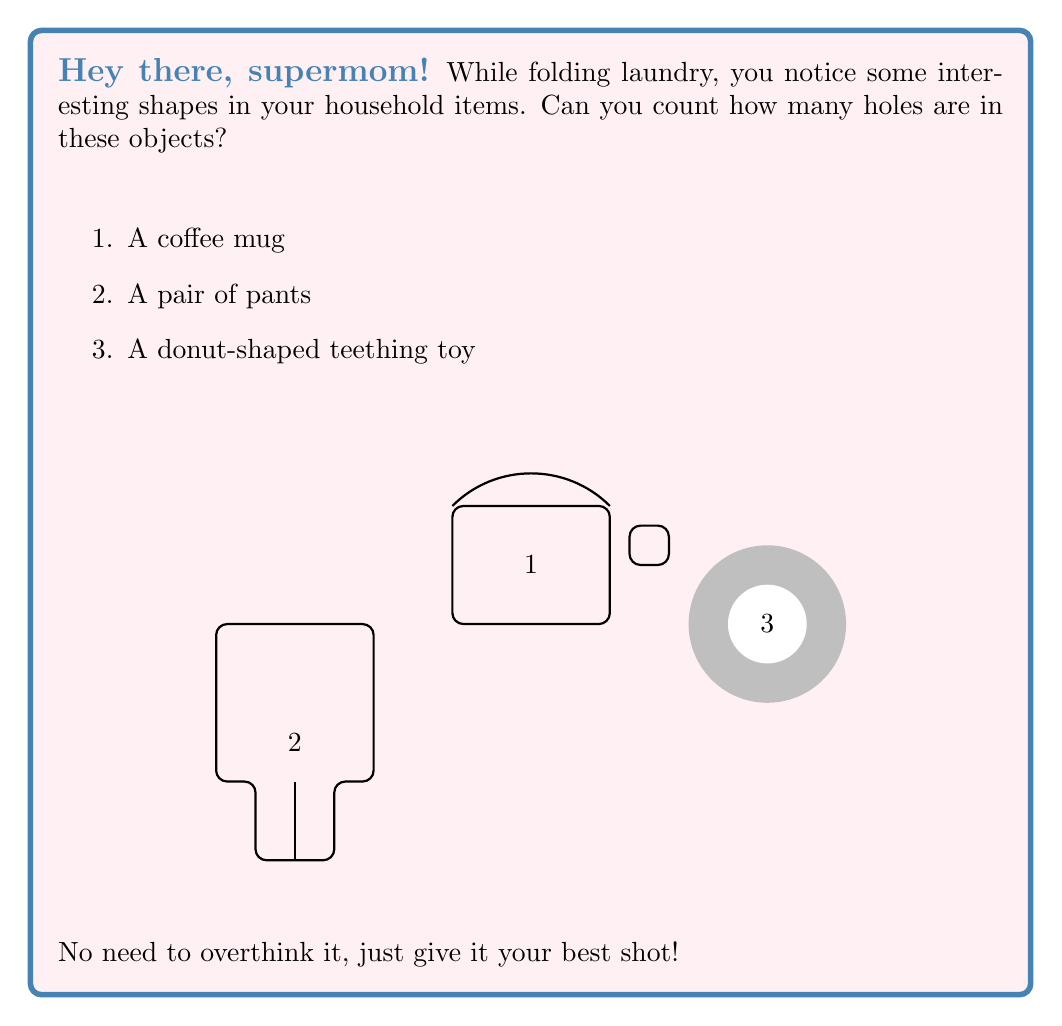What is the answer to this math problem? Alright, let's break this down step-by-step, keeping it simple and straightforward:

1. Coffee mug:
   - Look at the main body: it has one big opening at the top.
   - Now, check the handle: it creates another hole you can put your finger through.
   - Total holes: $1 + 1 = 2$

2. Pair of pants:
   - Start from the top: there's one big hole where you put your waist.
   - Now, look at the legs: each leg hole counts as one.
   - Total holes: $1 + 2 = 3$

3. Donut-shaped teething toy:
   - This one's easy! It's just like a real donut with one big hole in the middle.
   - Total holes: $1$

To get our final answer, we just need to add up all the holes we counted:

$$ \text{Total holes} = 2 + 3 + 1 = 6 $$

And that's it! No complicated math or boring instructions needed.
Answer: 6 